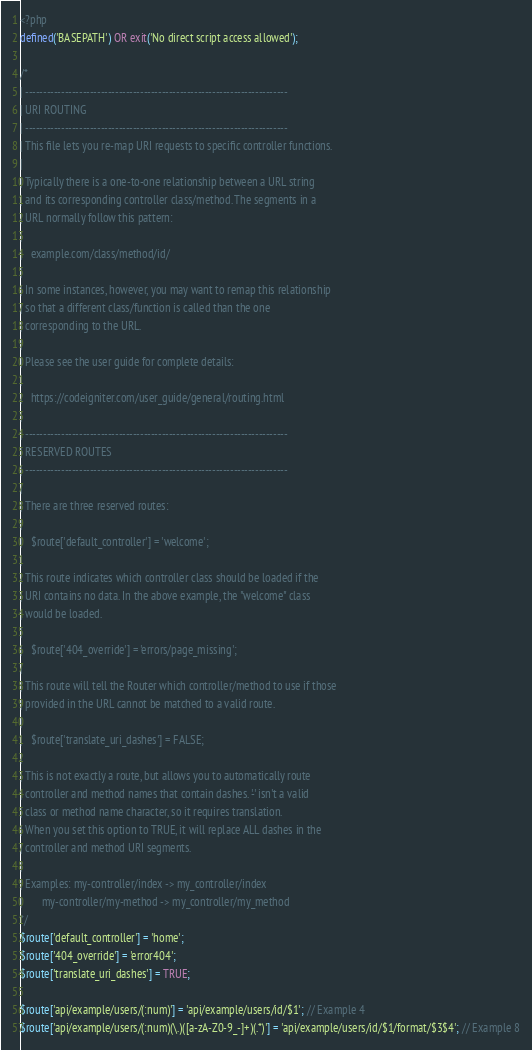<code> <loc_0><loc_0><loc_500><loc_500><_PHP_><?php
defined('BASEPATH') OR exit('No direct script access allowed');

/*
| -------------------------------------------------------------------------
| URI ROUTING
| -------------------------------------------------------------------------
| This file lets you re-map URI requests to specific controller functions.
|
| Typically there is a one-to-one relationship between a URL string
| and its corresponding controller class/method. The segments in a
| URL normally follow this pattern:
|
|	example.com/class/method/id/
|
| In some instances, however, you may want to remap this relationship
| so that a different class/function is called than the one
| corresponding to the URL.
|
| Please see the user guide for complete details:
|
|	https://codeigniter.com/user_guide/general/routing.html
|
| -------------------------------------------------------------------------
| RESERVED ROUTES
| -------------------------------------------------------------------------
|
| There are three reserved routes:
|
|	$route['default_controller'] = 'welcome';
|
| This route indicates which controller class should be loaded if the
| URI contains no data. In the above example, the "welcome" class
| would be loaded.
|
|	$route['404_override'] = 'errors/page_missing';
|
| This route will tell the Router which controller/method to use if those
| provided in the URL cannot be matched to a valid route.
|
|	$route['translate_uri_dashes'] = FALSE;
|
| This is not exactly a route, but allows you to automatically route
| controller and method names that contain dashes. '-' isn't a valid
| class or method name character, so it requires translation.
| When you set this option to TRUE, it will replace ALL dashes in the
| controller and method URI segments.
|
| Examples:	my-controller/index	-> my_controller/index
|		my-controller/my-method	-> my_controller/my_method
*/
$route['default_controller'] = 'home';
$route['404_override'] = 'error404';
$route['translate_uri_dashes'] = TRUE;

$route['api/example/users/(:num)'] = 'api/example/users/id/$1'; // Example 4
$route['api/example/users/(:num)(\.)([a-zA-Z0-9_-]+)(.*)'] = 'api/example/users/id/$1/format/$3$4'; // Example 8
</code> 